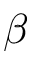Convert formula to latex. <formula><loc_0><loc_0><loc_500><loc_500>\beta</formula> 